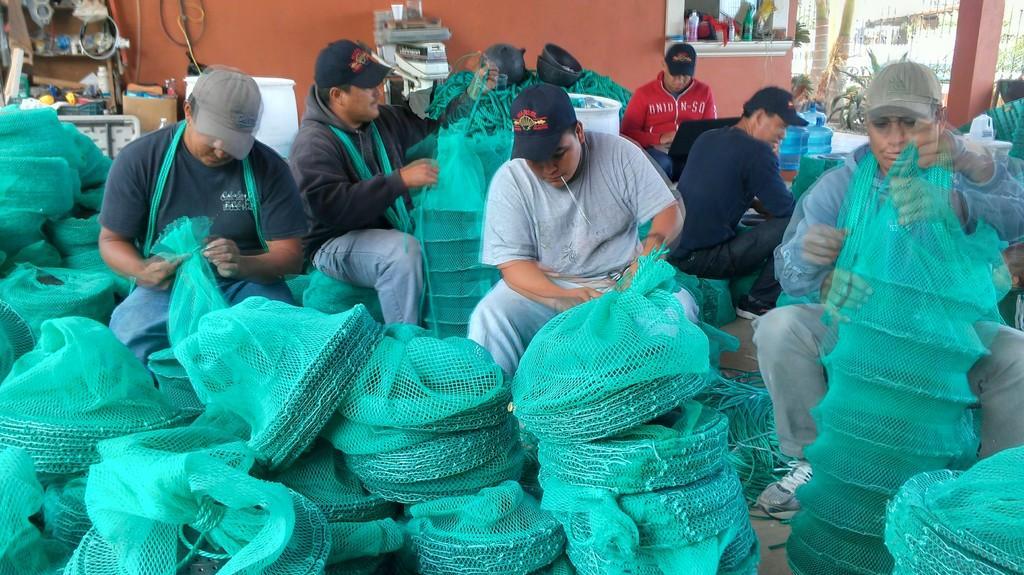How would you summarize this image in a sentence or two? There are group of people sitting in an area,they are manufacturing some products and sealing them with green covers and in the background there is a wall and beside the wall there is some equipment and machines. In the right side there are two trees and behind the trees there is a gate. 